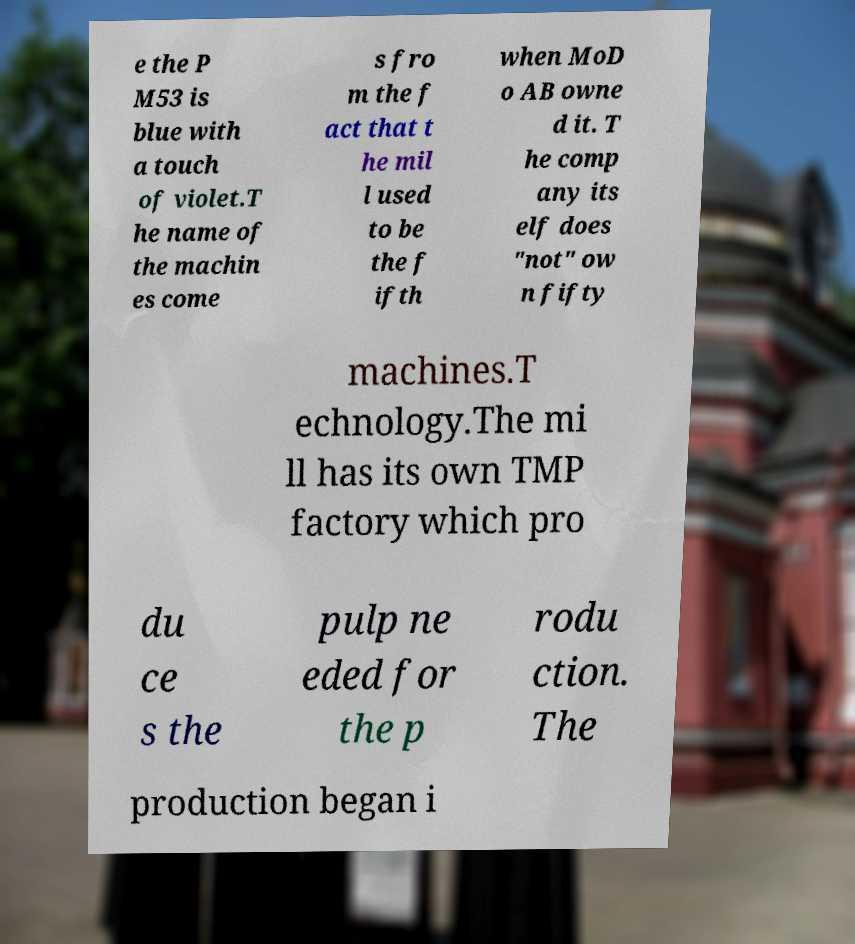For documentation purposes, I need the text within this image transcribed. Could you provide that? e the P M53 is blue with a touch of violet.T he name of the machin es come s fro m the f act that t he mil l used to be the f ifth when MoD o AB owne d it. T he comp any its elf does "not" ow n fifty machines.T echnology.The mi ll has its own TMP factory which pro du ce s the pulp ne eded for the p rodu ction. The production began i 